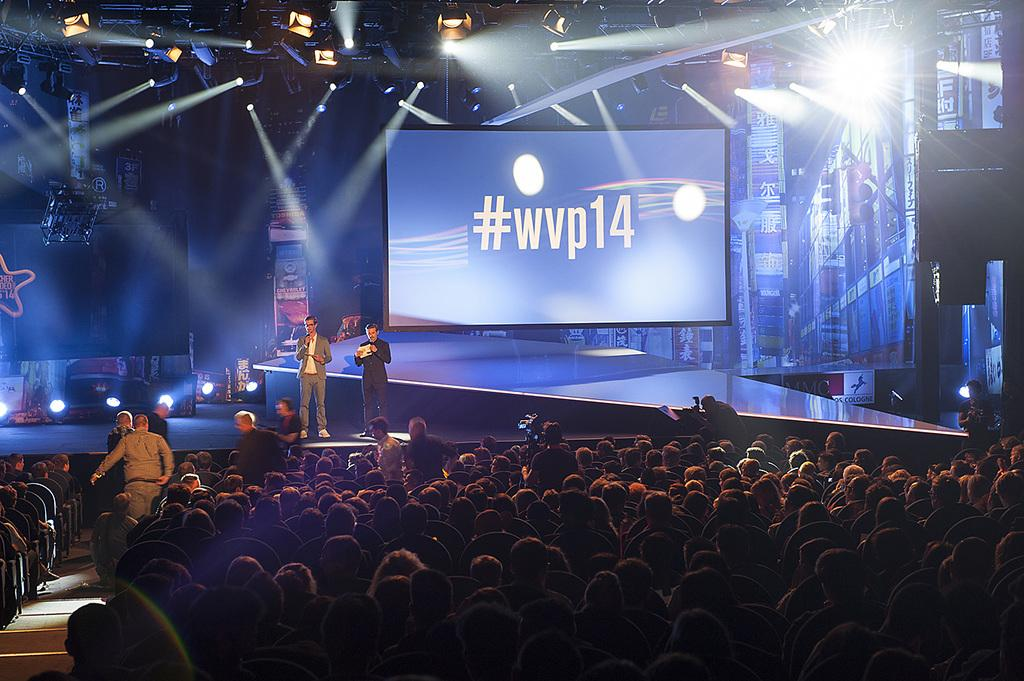<image>
Offer a succinct explanation of the picture presented. Men in stand in front of an auditorium full of people in front of a screen that reads #wvp14. 